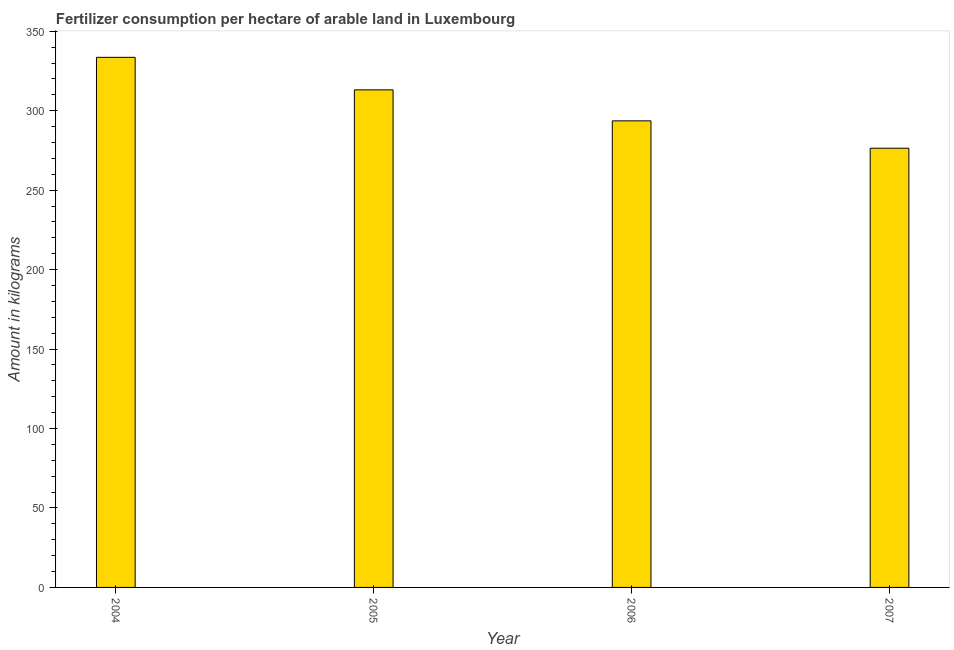Does the graph contain any zero values?
Ensure brevity in your answer.  No. Does the graph contain grids?
Make the answer very short. No. What is the title of the graph?
Offer a very short reply. Fertilizer consumption per hectare of arable land in Luxembourg . What is the label or title of the X-axis?
Offer a terse response. Year. What is the label or title of the Y-axis?
Offer a very short reply. Amount in kilograms. What is the amount of fertilizer consumption in 2006?
Keep it short and to the point. 293.63. Across all years, what is the maximum amount of fertilizer consumption?
Keep it short and to the point. 333.61. Across all years, what is the minimum amount of fertilizer consumption?
Your answer should be very brief. 276.41. In which year was the amount of fertilizer consumption maximum?
Offer a terse response. 2004. In which year was the amount of fertilizer consumption minimum?
Offer a very short reply. 2007. What is the sum of the amount of fertilizer consumption?
Keep it short and to the point. 1216.81. What is the difference between the amount of fertilizer consumption in 2005 and 2007?
Your response must be concise. 36.74. What is the average amount of fertilizer consumption per year?
Provide a succinct answer. 304.2. What is the median amount of fertilizer consumption?
Provide a succinct answer. 303.39. In how many years, is the amount of fertilizer consumption greater than 120 kg?
Make the answer very short. 4. What is the ratio of the amount of fertilizer consumption in 2005 to that in 2007?
Your answer should be very brief. 1.13. What is the difference between the highest and the second highest amount of fertilizer consumption?
Your answer should be very brief. 20.46. What is the difference between the highest and the lowest amount of fertilizer consumption?
Offer a terse response. 57.2. In how many years, is the amount of fertilizer consumption greater than the average amount of fertilizer consumption taken over all years?
Offer a very short reply. 2. How many bars are there?
Ensure brevity in your answer.  4. Are all the bars in the graph horizontal?
Your answer should be compact. No. What is the difference between two consecutive major ticks on the Y-axis?
Provide a short and direct response. 50. Are the values on the major ticks of Y-axis written in scientific E-notation?
Your response must be concise. No. What is the Amount in kilograms of 2004?
Your answer should be compact. 333.61. What is the Amount in kilograms of 2005?
Provide a succinct answer. 313.15. What is the Amount in kilograms in 2006?
Keep it short and to the point. 293.63. What is the Amount in kilograms of 2007?
Make the answer very short. 276.41. What is the difference between the Amount in kilograms in 2004 and 2005?
Provide a succinct answer. 20.46. What is the difference between the Amount in kilograms in 2004 and 2006?
Provide a short and direct response. 39.98. What is the difference between the Amount in kilograms in 2004 and 2007?
Provide a succinct answer. 57.2. What is the difference between the Amount in kilograms in 2005 and 2006?
Your response must be concise. 19.52. What is the difference between the Amount in kilograms in 2005 and 2007?
Your answer should be very brief. 36.74. What is the difference between the Amount in kilograms in 2006 and 2007?
Provide a succinct answer. 17.22. What is the ratio of the Amount in kilograms in 2004 to that in 2005?
Offer a very short reply. 1.06. What is the ratio of the Amount in kilograms in 2004 to that in 2006?
Provide a succinct answer. 1.14. What is the ratio of the Amount in kilograms in 2004 to that in 2007?
Offer a terse response. 1.21. What is the ratio of the Amount in kilograms in 2005 to that in 2006?
Give a very brief answer. 1.07. What is the ratio of the Amount in kilograms in 2005 to that in 2007?
Your answer should be very brief. 1.13. What is the ratio of the Amount in kilograms in 2006 to that in 2007?
Ensure brevity in your answer.  1.06. 